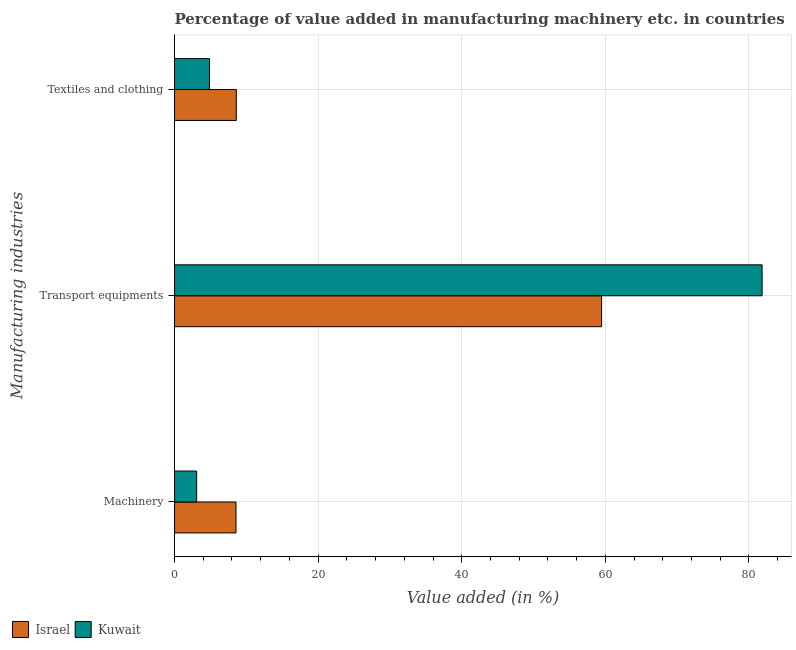How many groups of bars are there?
Your response must be concise. 3. How many bars are there on the 2nd tick from the top?
Your answer should be very brief. 2. What is the label of the 2nd group of bars from the top?
Your response must be concise. Transport equipments. What is the value added in manufacturing machinery in Israel?
Give a very brief answer. 8.56. Across all countries, what is the maximum value added in manufacturing transport equipments?
Keep it short and to the point. 81.84. Across all countries, what is the minimum value added in manufacturing transport equipments?
Keep it short and to the point. 59.48. In which country was the value added in manufacturing textile and clothing maximum?
Offer a very short reply. Israel. In which country was the value added in manufacturing textile and clothing minimum?
Your answer should be very brief. Kuwait. What is the total value added in manufacturing transport equipments in the graph?
Provide a short and direct response. 141.32. What is the difference between the value added in manufacturing machinery in Israel and that in Kuwait?
Keep it short and to the point. 5.48. What is the difference between the value added in manufacturing transport equipments in Kuwait and the value added in manufacturing textile and clothing in Israel?
Offer a very short reply. 73.24. What is the average value added in manufacturing machinery per country?
Your response must be concise. 5.82. What is the difference between the value added in manufacturing transport equipments and value added in manufacturing textile and clothing in Kuwait?
Keep it short and to the point. 76.97. What is the ratio of the value added in manufacturing transport equipments in Kuwait to that in Israel?
Your answer should be compact. 1.38. Is the value added in manufacturing machinery in Israel less than that in Kuwait?
Your response must be concise. No. What is the difference between the highest and the second highest value added in manufacturing transport equipments?
Offer a terse response. 22.36. What is the difference between the highest and the lowest value added in manufacturing transport equipments?
Your answer should be very brief. 22.36. What does the 1st bar from the top in Textiles and clothing represents?
Provide a succinct answer. Kuwait. What does the 2nd bar from the bottom in Machinery represents?
Ensure brevity in your answer.  Kuwait. Does the graph contain any zero values?
Make the answer very short. No. Does the graph contain grids?
Keep it short and to the point. Yes. Where does the legend appear in the graph?
Your response must be concise. Bottom left. What is the title of the graph?
Make the answer very short. Percentage of value added in manufacturing machinery etc. in countries. Does "Lower middle income" appear as one of the legend labels in the graph?
Make the answer very short. No. What is the label or title of the X-axis?
Keep it short and to the point. Value added (in %). What is the label or title of the Y-axis?
Provide a short and direct response. Manufacturing industries. What is the Value added (in %) of Israel in Machinery?
Your response must be concise. 8.56. What is the Value added (in %) in Kuwait in Machinery?
Your answer should be very brief. 3.08. What is the Value added (in %) of Israel in Transport equipments?
Ensure brevity in your answer.  59.48. What is the Value added (in %) of Kuwait in Transport equipments?
Your answer should be compact. 81.84. What is the Value added (in %) in Israel in Textiles and clothing?
Your answer should be very brief. 8.6. What is the Value added (in %) of Kuwait in Textiles and clothing?
Offer a very short reply. 4.87. Across all Manufacturing industries, what is the maximum Value added (in %) of Israel?
Your answer should be compact. 59.48. Across all Manufacturing industries, what is the maximum Value added (in %) of Kuwait?
Ensure brevity in your answer.  81.84. Across all Manufacturing industries, what is the minimum Value added (in %) in Israel?
Offer a very short reply. 8.56. Across all Manufacturing industries, what is the minimum Value added (in %) of Kuwait?
Offer a terse response. 3.08. What is the total Value added (in %) of Israel in the graph?
Ensure brevity in your answer.  76.64. What is the total Value added (in %) of Kuwait in the graph?
Offer a terse response. 89.78. What is the difference between the Value added (in %) of Israel in Machinery and that in Transport equipments?
Provide a short and direct response. -50.92. What is the difference between the Value added (in %) of Kuwait in Machinery and that in Transport equipments?
Keep it short and to the point. -78.76. What is the difference between the Value added (in %) of Israel in Machinery and that in Textiles and clothing?
Your answer should be very brief. -0.04. What is the difference between the Value added (in %) of Kuwait in Machinery and that in Textiles and clothing?
Ensure brevity in your answer.  -1.79. What is the difference between the Value added (in %) in Israel in Transport equipments and that in Textiles and clothing?
Give a very brief answer. 50.88. What is the difference between the Value added (in %) in Kuwait in Transport equipments and that in Textiles and clothing?
Keep it short and to the point. 76.97. What is the difference between the Value added (in %) in Israel in Machinery and the Value added (in %) in Kuwait in Transport equipments?
Your answer should be very brief. -73.28. What is the difference between the Value added (in %) in Israel in Machinery and the Value added (in %) in Kuwait in Textiles and clothing?
Offer a very short reply. 3.69. What is the difference between the Value added (in %) of Israel in Transport equipments and the Value added (in %) of Kuwait in Textiles and clothing?
Provide a succinct answer. 54.61. What is the average Value added (in %) in Israel per Manufacturing industries?
Offer a terse response. 25.55. What is the average Value added (in %) of Kuwait per Manufacturing industries?
Your answer should be very brief. 29.93. What is the difference between the Value added (in %) in Israel and Value added (in %) in Kuwait in Machinery?
Provide a succinct answer. 5.48. What is the difference between the Value added (in %) in Israel and Value added (in %) in Kuwait in Transport equipments?
Provide a short and direct response. -22.36. What is the difference between the Value added (in %) of Israel and Value added (in %) of Kuwait in Textiles and clothing?
Your answer should be compact. 3.73. What is the ratio of the Value added (in %) of Israel in Machinery to that in Transport equipments?
Your answer should be very brief. 0.14. What is the ratio of the Value added (in %) of Kuwait in Machinery to that in Transport equipments?
Offer a terse response. 0.04. What is the ratio of the Value added (in %) of Israel in Machinery to that in Textiles and clothing?
Keep it short and to the point. 1. What is the ratio of the Value added (in %) of Kuwait in Machinery to that in Textiles and clothing?
Your answer should be very brief. 0.63. What is the ratio of the Value added (in %) in Israel in Transport equipments to that in Textiles and clothing?
Your answer should be compact. 6.92. What is the ratio of the Value added (in %) of Kuwait in Transport equipments to that in Textiles and clothing?
Ensure brevity in your answer.  16.81. What is the difference between the highest and the second highest Value added (in %) of Israel?
Ensure brevity in your answer.  50.88. What is the difference between the highest and the second highest Value added (in %) of Kuwait?
Make the answer very short. 76.97. What is the difference between the highest and the lowest Value added (in %) of Israel?
Offer a very short reply. 50.92. What is the difference between the highest and the lowest Value added (in %) of Kuwait?
Provide a succinct answer. 78.76. 